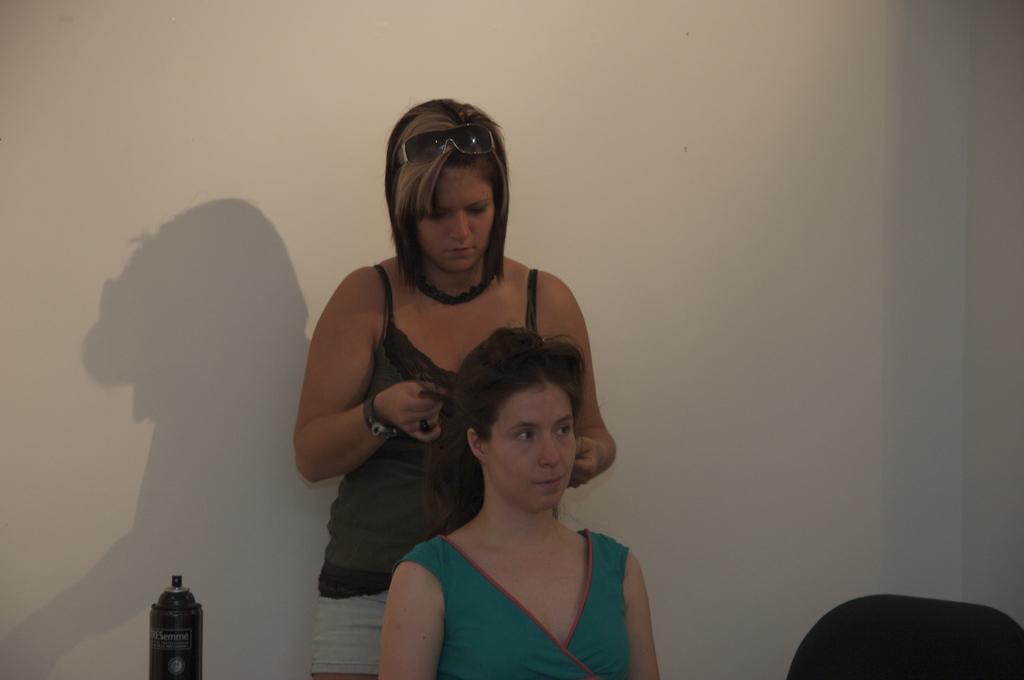Describe this image in one or two sentences. This picture shows a woman seated and a woman standing on the back and holding the hair with the hands of another woman and we see a spray bottle on the side and we see a chair and a wall on the back and women wore sunglasses on her head. 